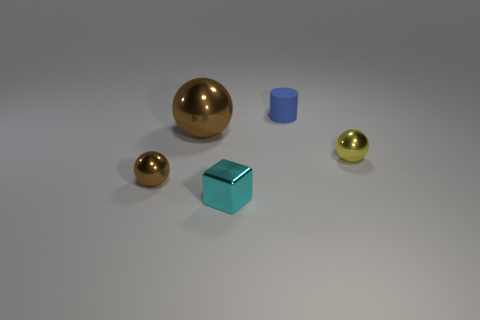There is a object that is behind the brown metal thing behind the tiny yellow shiny sphere; what number of blue matte objects are in front of it?
Give a very brief answer. 0. There is a tiny object left of the brown shiny object that is behind the tiny brown shiny thing; what is its color?
Ensure brevity in your answer.  Brown. What number of other objects are the same material as the tiny blue thing?
Make the answer very short. 0. There is a brown shiny ball behind the yellow metal object; how many yellow balls are on the right side of it?
Your answer should be very brief. 1. Are there any other things that are the same shape as the tiny cyan shiny thing?
Provide a succinct answer. No. Is the color of the small shiny sphere left of the large sphere the same as the shiny ball that is behind the tiny yellow sphere?
Your answer should be compact. Yes. Is the number of matte cylinders less than the number of large yellow metal cylinders?
Provide a succinct answer. No. What is the shape of the tiny thing that is behind the small ball on the right side of the tiny brown metal ball?
Provide a short and direct response. Cylinder. There is a object in front of the tiny metallic ball left of the brown sphere that is behind the tiny brown metallic ball; what is its shape?
Your answer should be compact. Cube. How many things are either tiny metallic objects to the right of the tiny blue object or things that are on the left side of the tiny rubber thing?
Make the answer very short. 4. 